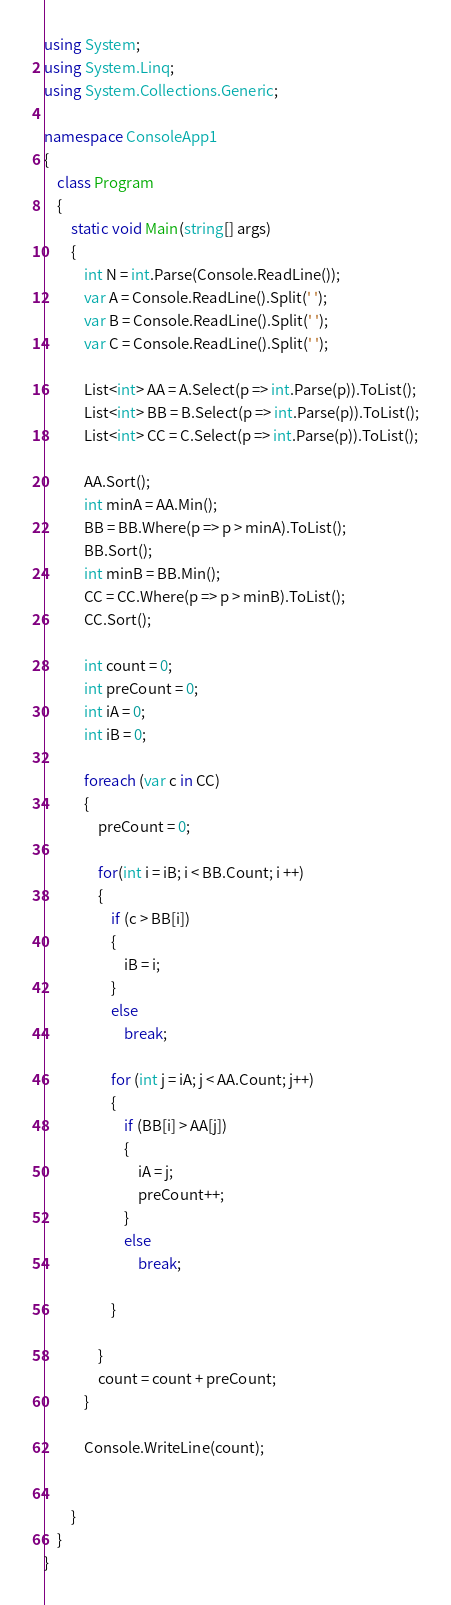<code> <loc_0><loc_0><loc_500><loc_500><_C#_>using System;
using System.Linq;
using System.Collections.Generic;

namespace ConsoleApp1
{
    class Program
    {
        static void Main(string[] args)
        {
            int N = int.Parse(Console.ReadLine());
            var A = Console.ReadLine().Split(' ');
            var B = Console.ReadLine().Split(' ');
            var C = Console.ReadLine().Split(' ');

            List<int> AA = A.Select(p => int.Parse(p)).ToList();
            List<int> BB = B.Select(p => int.Parse(p)).ToList();
            List<int> CC = C.Select(p => int.Parse(p)).ToList();

            AA.Sort();
            int minA = AA.Min();
            BB = BB.Where(p => p > minA).ToList();
            BB.Sort();
            int minB = BB.Min();
            CC = CC.Where(p => p > minB).ToList();
            CC.Sort();

            int count = 0;
            int preCount = 0;
            int iA = 0;
            int iB = 0;

            foreach (var c in CC)
            {
                preCount = 0;

                for(int i = iB; i < BB.Count; i ++)
                {
                    if (c > BB[i])
                    {
                        iB = i;
                    }
                    else
                        break;

                    for (int j = iA; j < AA.Count; j++)
                    {
                        if (BB[i] > AA[j])
                        {
                            iA = j;
                            preCount++;
                        }
                        else
                            break;

                    }

                }
                count = count + preCount;
            }

            Console.WriteLine(count);


        }
    }
}</code> 